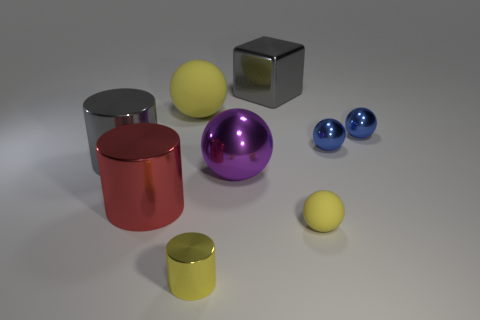Subtract all purple balls. How many balls are left? 4 Subtract 1 balls. How many balls are left? 4 Subtract all big metal spheres. How many spheres are left? 4 Subtract all green spheres. Subtract all purple blocks. How many spheres are left? 5 Subtract all balls. How many objects are left? 4 Subtract all blue things. Subtract all large shiny blocks. How many objects are left? 6 Add 4 big matte balls. How many big matte balls are left? 5 Add 8 big purple metallic balls. How many big purple metallic balls exist? 9 Subtract 0 brown cylinders. How many objects are left? 9 